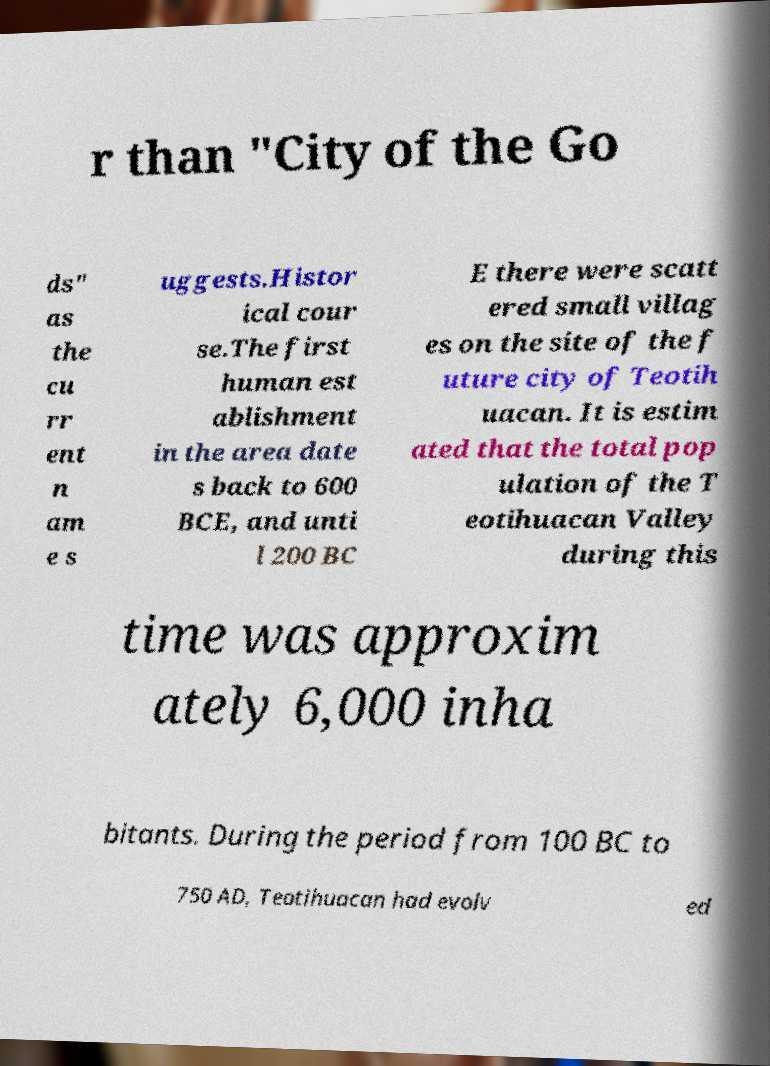Can you read and provide the text displayed in the image?This photo seems to have some interesting text. Can you extract and type it out for me? r than "City of the Go ds" as the cu rr ent n am e s uggests.Histor ical cour se.The first human est ablishment in the area date s back to 600 BCE, and unti l 200 BC E there were scatt ered small villag es on the site of the f uture city of Teotih uacan. It is estim ated that the total pop ulation of the T eotihuacan Valley during this time was approxim ately 6,000 inha bitants. During the period from 100 BC to 750 AD, Teotihuacan had evolv ed 